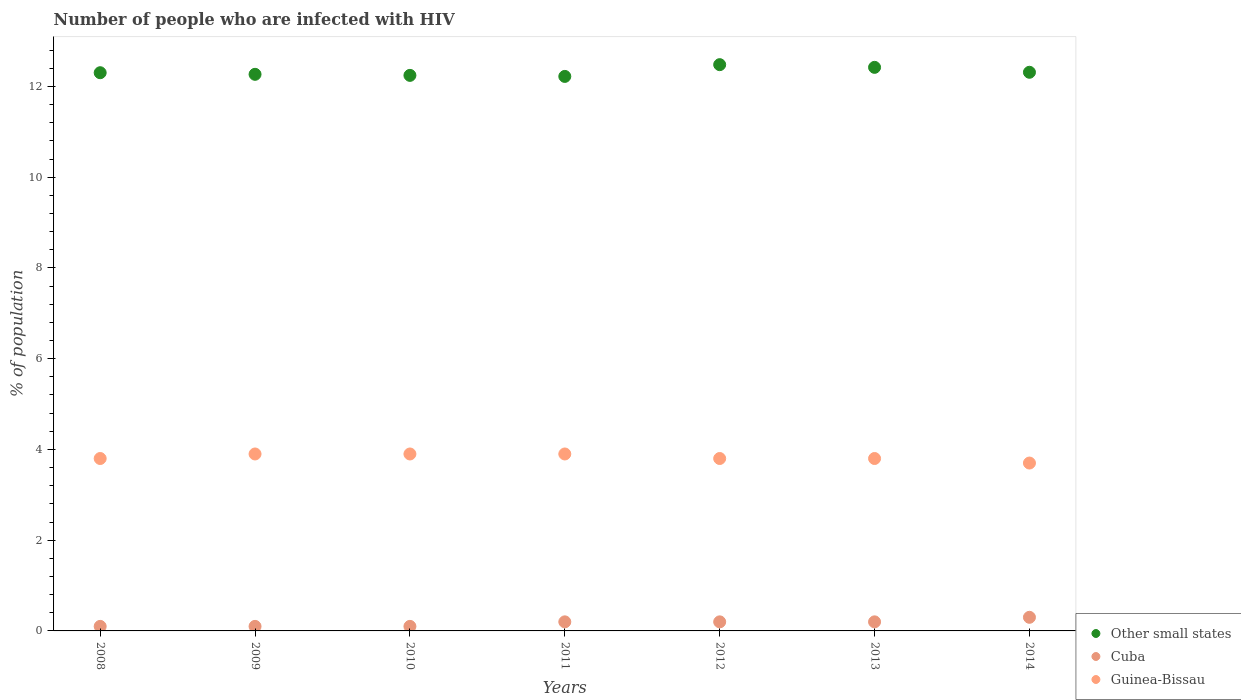How many different coloured dotlines are there?
Provide a short and direct response. 3. Is the number of dotlines equal to the number of legend labels?
Keep it short and to the point. Yes. What is the percentage of HIV infected population in in Other small states in 2010?
Offer a terse response. 12.24. Across all years, what is the maximum percentage of HIV infected population in in Other small states?
Provide a short and direct response. 12.48. Across all years, what is the minimum percentage of HIV infected population in in Cuba?
Provide a short and direct response. 0.1. In which year was the percentage of HIV infected population in in Guinea-Bissau maximum?
Provide a short and direct response. 2009. In which year was the percentage of HIV infected population in in Other small states minimum?
Ensure brevity in your answer.  2011. What is the total percentage of HIV infected population in in Other small states in the graph?
Your response must be concise. 86.25. What is the difference between the percentage of HIV infected population in in Other small states in 2014 and the percentage of HIV infected population in in Cuba in 2010?
Your answer should be very brief. 12.21. What is the average percentage of HIV infected population in in Cuba per year?
Your response must be concise. 0.17. In the year 2010, what is the difference between the percentage of HIV infected population in in Other small states and percentage of HIV infected population in in Guinea-Bissau?
Offer a terse response. 8.34. What is the ratio of the percentage of HIV infected population in in Guinea-Bissau in 2009 to that in 2012?
Provide a succinct answer. 1.03. Is the percentage of HIV infected population in in Other small states in 2010 less than that in 2011?
Make the answer very short. No. What is the difference between the highest and the second highest percentage of HIV infected population in in Cuba?
Your response must be concise. 0.1. What is the difference between the highest and the lowest percentage of HIV infected population in in Cuba?
Give a very brief answer. 0.2. Is the sum of the percentage of HIV infected population in in Other small states in 2012 and 2013 greater than the maximum percentage of HIV infected population in in Cuba across all years?
Your response must be concise. Yes. Is it the case that in every year, the sum of the percentage of HIV infected population in in Guinea-Bissau and percentage of HIV infected population in in Cuba  is greater than the percentage of HIV infected population in in Other small states?
Offer a very short reply. No. Is the percentage of HIV infected population in in Guinea-Bissau strictly greater than the percentage of HIV infected population in in Other small states over the years?
Offer a terse response. No. How many dotlines are there?
Keep it short and to the point. 3. How many years are there in the graph?
Make the answer very short. 7. What is the difference between two consecutive major ticks on the Y-axis?
Offer a very short reply. 2. Are the values on the major ticks of Y-axis written in scientific E-notation?
Ensure brevity in your answer.  No. Does the graph contain any zero values?
Make the answer very short. No. Where does the legend appear in the graph?
Make the answer very short. Bottom right. How are the legend labels stacked?
Your answer should be compact. Vertical. What is the title of the graph?
Offer a very short reply. Number of people who are infected with HIV. What is the label or title of the X-axis?
Keep it short and to the point. Years. What is the label or title of the Y-axis?
Your answer should be compact. % of population. What is the % of population in Other small states in 2008?
Make the answer very short. 12.3. What is the % of population of Cuba in 2008?
Make the answer very short. 0.1. What is the % of population of Guinea-Bissau in 2008?
Your answer should be very brief. 3.8. What is the % of population of Other small states in 2009?
Your answer should be very brief. 12.27. What is the % of population in Cuba in 2009?
Ensure brevity in your answer.  0.1. What is the % of population of Guinea-Bissau in 2009?
Give a very brief answer. 3.9. What is the % of population of Other small states in 2010?
Make the answer very short. 12.24. What is the % of population in Cuba in 2010?
Your answer should be compact. 0.1. What is the % of population of Guinea-Bissau in 2010?
Your answer should be compact. 3.9. What is the % of population of Other small states in 2011?
Offer a terse response. 12.22. What is the % of population of Guinea-Bissau in 2011?
Your answer should be very brief. 3.9. What is the % of population of Other small states in 2012?
Give a very brief answer. 12.48. What is the % of population in Cuba in 2012?
Offer a terse response. 0.2. What is the % of population of Guinea-Bissau in 2012?
Provide a short and direct response. 3.8. What is the % of population in Other small states in 2013?
Your answer should be very brief. 12.42. What is the % of population of Cuba in 2013?
Give a very brief answer. 0.2. What is the % of population in Guinea-Bissau in 2013?
Offer a very short reply. 3.8. What is the % of population of Other small states in 2014?
Your answer should be very brief. 12.31. What is the % of population of Cuba in 2014?
Ensure brevity in your answer.  0.3. What is the % of population in Guinea-Bissau in 2014?
Offer a very short reply. 3.7. Across all years, what is the maximum % of population of Other small states?
Your response must be concise. 12.48. Across all years, what is the maximum % of population of Cuba?
Your answer should be compact. 0.3. Across all years, what is the minimum % of population of Other small states?
Keep it short and to the point. 12.22. Across all years, what is the minimum % of population in Cuba?
Offer a terse response. 0.1. What is the total % of population of Other small states in the graph?
Offer a terse response. 86.25. What is the total % of population of Guinea-Bissau in the graph?
Make the answer very short. 26.8. What is the difference between the % of population of Other small states in 2008 and that in 2009?
Your answer should be very brief. 0.04. What is the difference between the % of population of Other small states in 2008 and that in 2010?
Provide a short and direct response. 0.06. What is the difference between the % of population in Cuba in 2008 and that in 2010?
Provide a succinct answer. 0. What is the difference between the % of population of Guinea-Bissau in 2008 and that in 2010?
Make the answer very short. -0.1. What is the difference between the % of population in Other small states in 2008 and that in 2011?
Keep it short and to the point. 0.08. What is the difference between the % of population of Other small states in 2008 and that in 2012?
Your answer should be compact. -0.18. What is the difference between the % of population in Cuba in 2008 and that in 2012?
Your answer should be very brief. -0.1. What is the difference between the % of population of Guinea-Bissau in 2008 and that in 2012?
Provide a short and direct response. 0. What is the difference between the % of population of Other small states in 2008 and that in 2013?
Provide a succinct answer. -0.12. What is the difference between the % of population of Cuba in 2008 and that in 2013?
Provide a succinct answer. -0.1. What is the difference between the % of population of Other small states in 2008 and that in 2014?
Provide a succinct answer. -0.01. What is the difference between the % of population of Guinea-Bissau in 2008 and that in 2014?
Provide a short and direct response. 0.1. What is the difference between the % of population of Other small states in 2009 and that in 2010?
Offer a very short reply. 0.02. What is the difference between the % of population of Cuba in 2009 and that in 2010?
Keep it short and to the point. 0. What is the difference between the % of population in Guinea-Bissau in 2009 and that in 2010?
Give a very brief answer. 0. What is the difference between the % of population of Other small states in 2009 and that in 2011?
Your response must be concise. 0.05. What is the difference between the % of population in Cuba in 2009 and that in 2011?
Ensure brevity in your answer.  -0.1. What is the difference between the % of population of Other small states in 2009 and that in 2012?
Your response must be concise. -0.21. What is the difference between the % of population of Cuba in 2009 and that in 2012?
Give a very brief answer. -0.1. What is the difference between the % of population of Other small states in 2009 and that in 2013?
Your answer should be compact. -0.15. What is the difference between the % of population in Cuba in 2009 and that in 2013?
Keep it short and to the point. -0.1. What is the difference between the % of population of Guinea-Bissau in 2009 and that in 2013?
Provide a succinct answer. 0.1. What is the difference between the % of population in Other small states in 2009 and that in 2014?
Offer a terse response. -0.05. What is the difference between the % of population in Cuba in 2009 and that in 2014?
Your answer should be very brief. -0.2. What is the difference between the % of population of Other small states in 2010 and that in 2011?
Ensure brevity in your answer.  0.02. What is the difference between the % of population of Guinea-Bissau in 2010 and that in 2011?
Provide a succinct answer. 0. What is the difference between the % of population of Other small states in 2010 and that in 2012?
Make the answer very short. -0.24. What is the difference between the % of population of Other small states in 2010 and that in 2013?
Your response must be concise. -0.18. What is the difference between the % of population in Cuba in 2010 and that in 2013?
Make the answer very short. -0.1. What is the difference between the % of population in Guinea-Bissau in 2010 and that in 2013?
Ensure brevity in your answer.  0.1. What is the difference between the % of population in Other small states in 2010 and that in 2014?
Offer a terse response. -0.07. What is the difference between the % of population in Cuba in 2010 and that in 2014?
Ensure brevity in your answer.  -0.2. What is the difference between the % of population of Guinea-Bissau in 2010 and that in 2014?
Offer a very short reply. 0.2. What is the difference between the % of population in Other small states in 2011 and that in 2012?
Give a very brief answer. -0.26. What is the difference between the % of population of Guinea-Bissau in 2011 and that in 2012?
Your answer should be compact. 0.1. What is the difference between the % of population of Other small states in 2011 and that in 2013?
Keep it short and to the point. -0.2. What is the difference between the % of population of Guinea-Bissau in 2011 and that in 2013?
Ensure brevity in your answer.  0.1. What is the difference between the % of population of Other small states in 2011 and that in 2014?
Your response must be concise. -0.09. What is the difference between the % of population in Other small states in 2012 and that in 2013?
Your answer should be compact. 0.06. What is the difference between the % of population of Cuba in 2012 and that in 2013?
Your response must be concise. 0. What is the difference between the % of population of Other small states in 2012 and that in 2014?
Offer a very short reply. 0.17. What is the difference between the % of population of Cuba in 2012 and that in 2014?
Your response must be concise. -0.1. What is the difference between the % of population in Other small states in 2013 and that in 2014?
Keep it short and to the point. 0.11. What is the difference between the % of population of Guinea-Bissau in 2013 and that in 2014?
Your response must be concise. 0.1. What is the difference between the % of population in Other small states in 2008 and the % of population in Cuba in 2009?
Your answer should be compact. 12.2. What is the difference between the % of population in Other small states in 2008 and the % of population in Guinea-Bissau in 2009?
Give a very brief answer. 8.4. What is the difference between the % of population of Other small states in 2008 and the % of population of Cuba in 2010?
Offer a terse response. 12.2. What is the difference between the % of population of Other small states in 2008 and the % of population of Guinea-Bissau in 2010?
Give a very brief answer. 8.4. What is the difference between the % of population in Cuba in 2008 and the % of population in Guinea-Bissau in 2010?
Ensure brevity in your answer.  -3.8. What is the difference between the % of population of Other small states in 2008 and the % of population of Cuba in 2011?
Ensure brevity in your answer.  12.1. What is the difference between the % of population of Other small states in 2008 and the % of population of Guinea-Bissau in 2011?
Offer a terse response. 8.4. What is the difference between the % of population in Other small states in 2008 and the % of population in Cuba in 2012?
Give a very brief answer. 12.1. What is the difference between the % of population in Other small states in 2008 and the % of population in Guinea-Bissau in 2012?
Offer a terse response. 8.5. What is the difference between the % of population in Cuba in 2008 and the % of population in Guinea-Bissau in 2012?
Give a very brief answer. -3.7. What is the difference between the % of population in Other small states in 2008 and the % of population in Cuba in 2013?
Offer a terse response. 12.1. What is the difference between the % of population in Other small states in 2008 and the % of population in Guinea-Bissau in 2013?
Provide a short and direct response. 8.5. What is the difference between the % of population in Cuba in 2008 and the % of population in Guinea-Bissau in 2013?
Provide a short and direct response. -3.7. What is the difference between the % of population in Other small states in 2008 and the % of population in Cuba in 2014?
Your answer should be very brief. 12. What is the difference between the % of population in Other small states in 2008 and the % of population in Guinea-Bissau in 2014?
Offer a terse response. 8.6. What is the difference between the % of population of Cuba in 2008 and the % of population of Guinea-Bissau in 2014?
Your response must be concise. -3.6. What is the difference between the % of population of Other small states in 2009 and the % of population of Cuba in 2010?
Your response must be concise. 12.17. What is the difference between the % of population of Other small states in 2009 and the % of population of Guinea-Bissau in 2010?
Make the answer very short. 8.37. What is the difference between the % of population of Other small states in 2009 and the % of population of Cuba in 2011?
Your response must be concise. 12.07. What is the difference between the % of population in Other small states in 2009 and the % of population in Guinea-Bissau in 2011?
Provide a short and direct response. 8.37. What is the difference between the % of population of Other small states in 2009 and the % of population of Cuba in 2012?
Your answer should be compact. 12.07. What is the difference between the % of population of Other small states in 2009 and the % of population of Guinea-Bissau in 2012?
Keep it short and to the point. 8.47. What is the difference between the % of population of Other small states in 2009 and the % of population of Cuba in 2013?
Your response must be concise. 12.07. What is the difference between the % of population of Other small states in 2009 and the % of population of Guinea-Bissau in 2013?
Offer a terse response. 8.47. What is the difference between the % of population in Cuba in 2009 and the % of population in Guinea-Bissau in 2013?
Ensure brevity in your answer.  -3.7. What is the difference between the % of population of Other small states in 2009 and the % of population of Cuba in 2014?
Make the answer very short. 11.97. What is the difference between the % of population in Other small states in 2009 and the % of population in Guinea-Bissau in 2014?
Your answer should be very brief. 8.57. What is the difference between the % of population in Other small states in 2010 and the % of population in Cuba in 2011?
Provide a succinct answer. 12.04. What is the difference between the % of population in Other small states in 2010 and the % of population in Guinea-Bissau in 2011?
Ensure brevity in your answer.  8.34. What is the difference between the % of population in Other small states in 2010 and the % of population in Cuba in 2012?
Provide a short and direct response. 12.04. What is the difference between the % of population in Other small states in 2010 and the % of population in Guinea-Bissau in 2012?
Ensure brevity in your answer.  8.44. What is the difference between the % of population in Cuba in 2010 and the % of population in Guinea-Bissau in 2012?
Your response must be concise. -3.7. What is the difference between the % of population of Other small states in 2010 and the % of population of Cuba in 2013?
Offer a terse response. 12.04. What is the difference between the % of population of Other small states in 2010 and the % of population of Guinea-Bissau in 2013?
Provide a short and direct response. 8.44. What is the difference between the % of population of Other small states in 2010 and the % of population of Cuba in 2014?
Ensure brevity in your answer.  11.94. What is the difference between the % of population of Other small states in 2010 and the % of population of Guinea-Bissau in 2014?
Make the answer very short. 8.54. What is the difference between the % of population in Cuba in 2010 and the % of population in Guinea-Bissau in 2014?
Give a very brief answer. -3.6. What is the difference between the % of population of Other small states in 2011 and the % of population of Cuba in 2012?
Provide a succinct answer. 12.02. What is the difference between the % of population of Other small states in 2011 and the % of population of Guinea-Bissau in 2012?
Ensure brevity in your answer.  8.42. What is the difference between the % of population of Cuba in 2011 and the % of population of Guinea-Bissau in 2012?
Your answer should be very brief. -3.6. What is the difference between the % of population in Other small states in 2011 and the % of population in Cuba in 2013?
Offer a very short reply. 12.02. What is the difference between the % of population in Other small states in 2011 and the % of population in Guinea-Bissau in 2013?
Your answer should be compact. 8.42. What is the difference between the % of population in Cuba in 2011 and the % of population in Guinea-Bissau in 2013?
Provide a succinct answer. -3.6. What is the difference between the % of population in Other small states in 2011 and the % of population in Cuba in 2014?
Keep it short and to the point. 11.92. What is the difference between the % of population in Other small states in 2011 and the % of population in Guinea-Bissau in 2014?
Your answer should be compact. 8.52. What is the difference between the % of population in Cuba in 2011 and the % of population in Guinea-Bissau in 2014?
Your answer should be compact. -3.5. What is the difference between the % of population in Other small states in 2012 and the % of population in Cuba in 2013?
Give a very brief answer. 12.28. What is the difference between the % of population of Other small states in 2012 and the % of population of Guinea-Bissau in 2013?
Provide a succinct answer. 8.68. What is the difference between the % of population of Cuba in 2012 and the % of population of Guinea-Bissau in 2013?
Your response must be concise. -3.6. What is the difference between the % of population of Other small states in 2012 and the % of population of Cuba in 2014?
Your answer should be compact. 12.18. What is the difference between the % of population of Other small states in 2012 and the % of population of Guinea-Bissau in 2014?
Your answer should be compact. 8.78. What is the difference between the % of population in Other small states in 2013 and the % of population in Cuba in 2014?
Provide a short and direct response. 12.12. What is the difference between the % of population of Other small states in 2013 and the % of population of Guinea-Bissau in 2014?
Your answer should be very brief. 8.72. What is the average % of population of Other small states per year?
Give a very brief answer. 12.32. What is the average % of population of Cuba per year?
Provide a short and direct response. 0.17. What is the average % of population in Guinea-Bissau per year?
Ensure brevity in your answer.  3.83. In the year 2008, what is the difference between the % of population in Other small states and % of population in Cuba?
Offer a very short reply. 12.2. In the year 2008, what is the difference between the % of population of Other small states and % of population of Guinea-Bissau?
Offer a terse response. 8.5. In the year 2008, what is the difference between the % of population in Cuba and % of population in Guinea-Bissau?
Keep it short and to the point. -3.7. In the year 2009, what is the difference between the % of population of Other small states and % of population of Cuba?
Your answer should be compact. 12.17. In the year 2009, what is the difference between the % of population in Other small states and % of population in Guinea-Bissau?
Your answer should be very brief. 8.37. In the year 2010, what is the difference between the % of population of Other small states and % of population of Cuba?
Offer a very short reply. 12.14. In the year 2010, what is the difference between the % of population in Other small states and % of population in Guinea-Bissau?
Make the answer very short. 8.34. In the year 2011, what is the difference between the % of population of Other small states and % of population of Cuba?
Your answer should be very brief. 12.02. In the year 2011, what is the difference between the % of population in Other small states and % of population in Guinea-Bissau?
Your answer should be compact. 8.32. In the year 2011, what is the difference between the % of population in Cuba and % of population in Guinea-Bissau?
Your response must be concise. -3.7. In the year 2012, what is the difference between the % of population of Other small states and % of population of Cuba?
Your response must be concise. 12.28. In the year 2012, what is the difference between the % of population in Other small states and % of population in Guinea-Bissau?
Ensure brevity in your answer.  8.68. In the year 2012, what is the difference between the % of population of Cuba and % of population of Guinea-Bissau?
Ensure brevity in your answer.  -3.6. In the year 2013, what is the difference between the % of population in Other small states and % of population in Cuba?
Make the answer very short. 12.22. In the year 2013, what is the difference between the % of population of Other small states and % of population of Guinea-Bissau?
Give a very brief answer. 8.62. In the year 2013, what is the difference between the % of population of Cuba and % of population of Guinea-Bissau?
Give a very brief answer. -3.6. In the year 2014, what is the difference between the % of population in Other small states and % of population in Cuba?
Your answer should be compact. 12.01. In the year 2014, what is the difference between the % of population in Other small states and % of population in Guinea-Bissau?
Provide a succinct answer. 8.61. In the year 2014, what is the difference between the % of population of Cuba and % of population of Guinea-Bissau?
Offer a very short reply. -3.4. What is the ratio of the % of population in Guinea-Bissau in 2008 to that in 2009?
Ensure brevity in your answer.  0.97. What is the ratio of the % of population of Guinea-Bissau in 2008 to that in 2010?
Provide a short and direct response. 0.97. What is the ratio of the % of population in Other small states in 2008 to that in 2011?
Provide a short and direct response. 1.01. What is the ratio of the % of population in Cuba in 2008 to that in 2011?
Ensure brevity in your answer.  0.5. What is the ratio of the % of population of Guinea-Bissau in 2008 to that in 2011?
Provide a succinct answer. 0.97. What is the ratio of the % of population in Other small states in 2008 to that in 2012?
Give a very brief answer. 0.99. What is the ratio of the % of population in Cuba in 2008 to that in 2012?
Offer a very short reply. 0.5. What is the ratio of the % of population in Cuba in 2008 to that in 2013?
Your answer should be compact. 0.5. What is the ratio of the % of population in Other small states in 2008 to that in 2014?
Ensure brevity in your answer.  1. What is the ratio of the % of population of Cuba in 2008 to that in 2014?
Provide a succinct answer. 0.33. What is the ratio of the % of population of Cuba in 2009 to that in 2011?
Provide a short and direct response. 0.5. What is the ratio of the % of population in Guinea-Bissau in 2009 to that in 2011?
Keep it short and to the point. 1. What is the ratio of the % of population in Other small states in 2009 to that in 2012?
Provide a short and direct response. 0.98. What is the ratio of the % of population in Cuba in 2009 to that in 2012?
Your answer should be very brief. 0.5. What is the ratio of the % of population of Guinea-Bissau in 2009 to that in 2012?
Your response must be concise. 1.03. What is the ratio of the % of population of Other small states in 2009 to that in 2013?
Make the answer very short. 0.99. What is the ratio of the % of population of Guinea-Bissau in 2009 to that in 2013?
Provide a short and direct response. 1.03. What is the ratio of the % of population in Cuba in 2009 to that in 2014?
Offer a very short reply. 0.33. What is the ratio of the % of population of Guinea-Bissau in 2009 to that in 2014?
Your answer should be compact. 1.05. What is the ratio of the % of population of Other small states in 2010 to that in 2011?
Your response must be concise. 1. What is the ratio of the % of population in Other small states in 2010 to that in 2012?
Your answer should be very brief. 0.98. What is the ratio of the % of population of Guinea-Bissau in 2010 to that in 2012?
Your answer should be very brief. 1.03. What is the ratio of the % of population in Other small states in 2010 to that in 2013?
Provide a succinct answer. 0.99. What is the ratio of the % of population of Guinea-Bissau in 2010 to that in 2013?
Your response must be concise. 1.03. What is the ratio of the % of population in Other small states in 2010 to that in 2014?
Keep it short and to the point. 0.99. What is the ratio of the % of population in Guinea-Bissau in 2010 to that in 2014?
Make the answer very short. 1.05. What is the ratio of the % of population of Other small states in 2011 to that in 2012?
Your answer should be very brief. 0.98. What is the ratio of the % of population in Cuba in 2011 to that in 2012?
Offer a very short reply. 1. What is the ratio of the % of population of Guinea-Bissau in 2011 to that in 2012?
Make the answer very short. 1.03. What is the ratio of the % of population of Other small states in 2011 to that in 2013?
Make the answer very short. 0.98. What is the ratio of the % of population of Cuba in 2011 to that in 2013?
Offer a terse response. 1. What is the ratio of the % of population in Guinea-Bissau in 2011 to that in 2013?
Give a very brief answer. 1.03. What is the ratio of the % of population in Guinea-Bissau in 2011 to that in 2014?
Provide a short and direct response. 1.05. What is the ratio of the % of population in Other small states in 2012 to that in 2013?
Provide a succinct answer. 1. What is the ratio of the % of population in Guinea-Bissau in 2012 to that in 2013?
Keep it short and to the point. 1. What is the ratio of the % of population in Other small states in 2012 to that in 2014?
Provide a succinct answer. 1.01. What is the ratio of the % of population in Other small states in 2013 to that in 2014?
Your response must be concise. 1.01. What is the ratio of the % of population in Cuba in 2013 to that in 2014?
Provide a succinct answer. 0.67. What is the difference between the highest and the second highest % of population in Other small states?
Keep it short and to the point. 0.06. What is the difference between the highest and the lowest % of population in Other small states?
Your answer should be very brief. 0.26. What is the difference between the highest and the lowest % of population in Cuba?
Your answer should be compact. 0.2. 